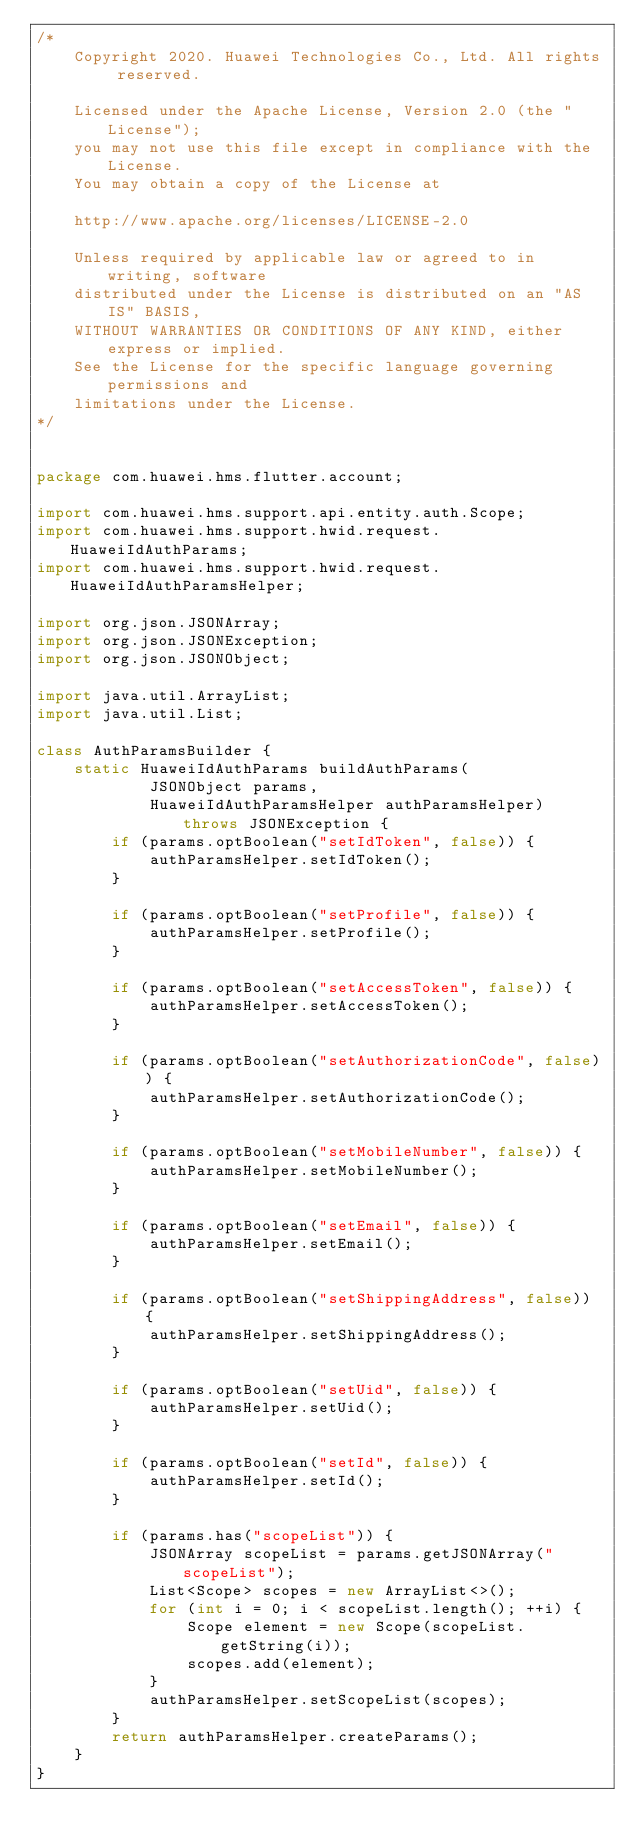Convert code to text. <code><loc_0><loc_0><loc_500><loc_500><_Java_>/*
    Copyright 2020. Huawei Technologies Co., Ltd. All rights reserved.

    Licensed under the Apache License, Version 2.0 (the "License");
    you may not use this file except in compliance with the License.
    You may obtain a copy of the License at

    http://www.apache.org/licenses/LICENSE-2.0

    Unless required by applicable law or agreed to in writing, software
    distributed under the License is distributed on an "AS IS" BASIS,
    WITHOUT WARRANTIES OR CONDITIONS OF ANY KIND, either express or implied.
    See the License for the specific language governing permissions and
    limitations under the License.
*/


package com.huawei.hms.flutter.account;

import com.huawei.hms.support.api.entity.auth.Scope;
import com.huawei.hms.support.hwid.request.HuaweiIdAuthParams;
import com.huawei.hms.support.hwid.request.HuaweiIdAuthParamsHelper;

import org.json.JSONArray;
import org.json.JSONException;
import org.json.JSONObject;

import java.util.ArrayList;
import java.util.List;

class AuthParamsBuilder {
    static HuaweiIdAuthParams buildAuthParams(
            JSONObject params,
            HuaweiIdAuthParamsHelper authParamsHelper) throws JSONException {
        if (params.optBoolean("setIdToken", false)) {
            authParamsHelper.setIdToken();
        }

        if (params.optBoolean("setProfile", false)) {
            authParamsHelper.setProfile();
        }

        if (params.optBoolean("setAccessToken", false)) {
            authParamsHelper.setAccessToken();
        }

        if (params.optBoolean("setAuthorizationCode", false)) {
            authParamsHelper.setAuthorizationCode();
        }

        if (params.optBoolean("setMobileNumber", false)) {
            authParamsHelper.setMobileNumber();
        }

        if (params.optBoolean("setEmail", false)) {
            authParamsHelper.setEmail();
        }

        if (params.optBoolean("setShippingAddress", false)) {
            authParamsHelper.setShippingAddress();
        }

        if (params.optBoolean("setUid", false)) {
            authParamsHelper.setUid();
        }

        if (params.optBoolean("setId", false)) {
            authParamsHelper.setId();
        }

        if (params.has("scopeList")) {
            JSONArray scopeList = params.getJSONArray("scopeList");
            List<Scope> scopes = new ArrayList<>();
            for (int i = 0; i < scopeList.length(); ++i) {
                Scope element = new Scope(scopeList.getString(i));
                scopes.add(element);
            }
            authParamsHelper.setScopeList(scopes);
        }
        return authParamsHelper.createParams();
    }
}
</code> 